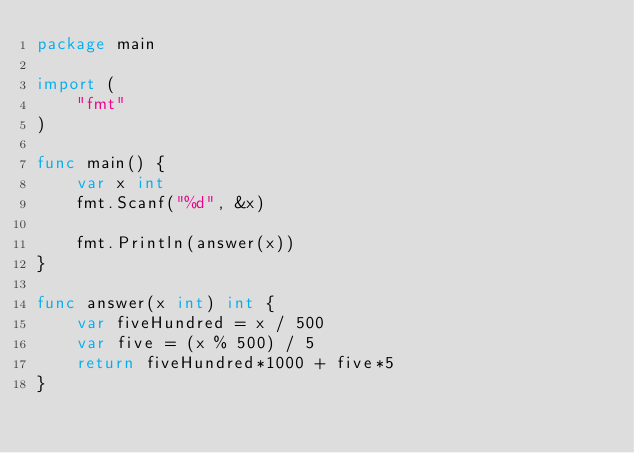Convert code to text. <code><loc_0><loc_0><loc_500><loc_500><_Go_>package main

import (
	"fmt"
)

func main() {
	var x int
	fmt.Scanf("%d", &x)

	fmt.Println(answer(x))
}

func answer(x int) int {
	var fiveHundred = x / 500
	var five = (x % 500) / 5
	return fiveHundred*1000 + five*5
}
</code> 